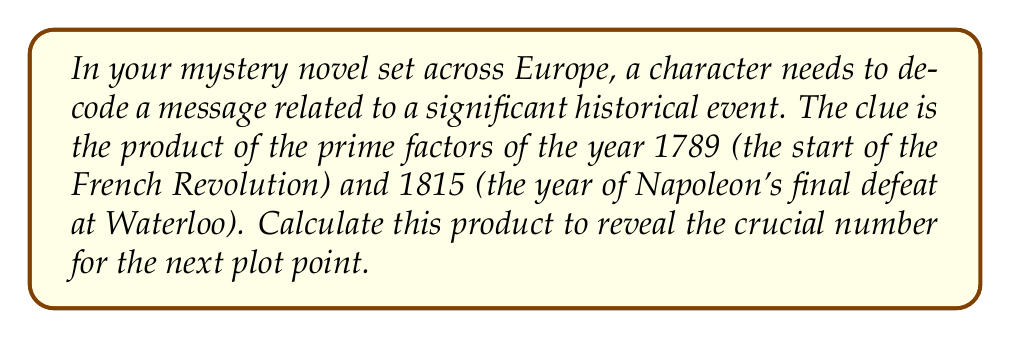Teach me how to tackle this problem. Let's approach this step-by-step:

1) First, we need to find the prime factors of 1789 and 1815.

2) For 1789:
   $1789 = 13 \times 137$
   Both 13 and 137 are prime numbers.

3) For 1815:
   $1815 = 3 \times 5 \times 11 \times 11$
   3, 5, and 11 are all prime numbers.

4) Now, we need to multiply all these prime factors together:

   $$13 \times 137 \times 3 \times 5 \times 11 \times 11$$

5) Let's calculate this:
   $13 \times 137 = 1,781$
   $1,781 \times 3 = 5,343$
   $5,343 \times 5 = 26,715$
   $26,715 \times 11 = 293,865$
   $293,865 \times 11 = 3,232,515$

Therefore, the product of all prime factors is 3,232,515.
Answer: 3,232,515 